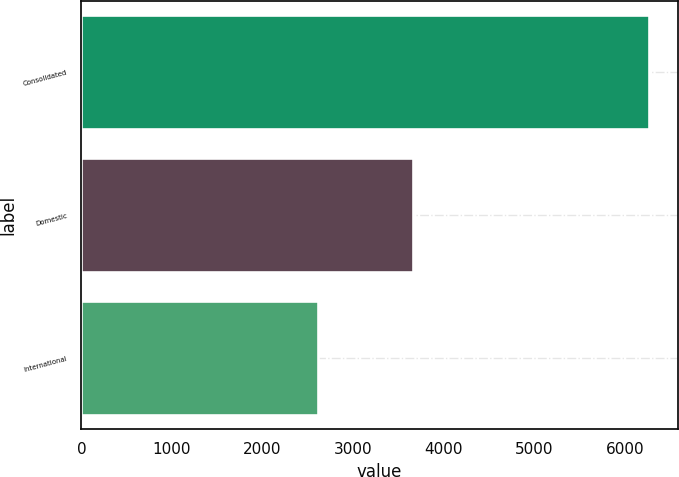Convert chart to OTSL. <chart><loc_0><loc_0><loc_500><loc_500><bar_chart><fcel>Consolidated<fcel>Domestic<fcel>International<nl><fcel>6266.7<fcel>3660.6<fcel>2606.1<nl></chart> 